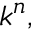<formula> <loc_0><loc_0><loc_500><loc_500>{ \mathfrak { k } } ^ { n } ,</formula> 